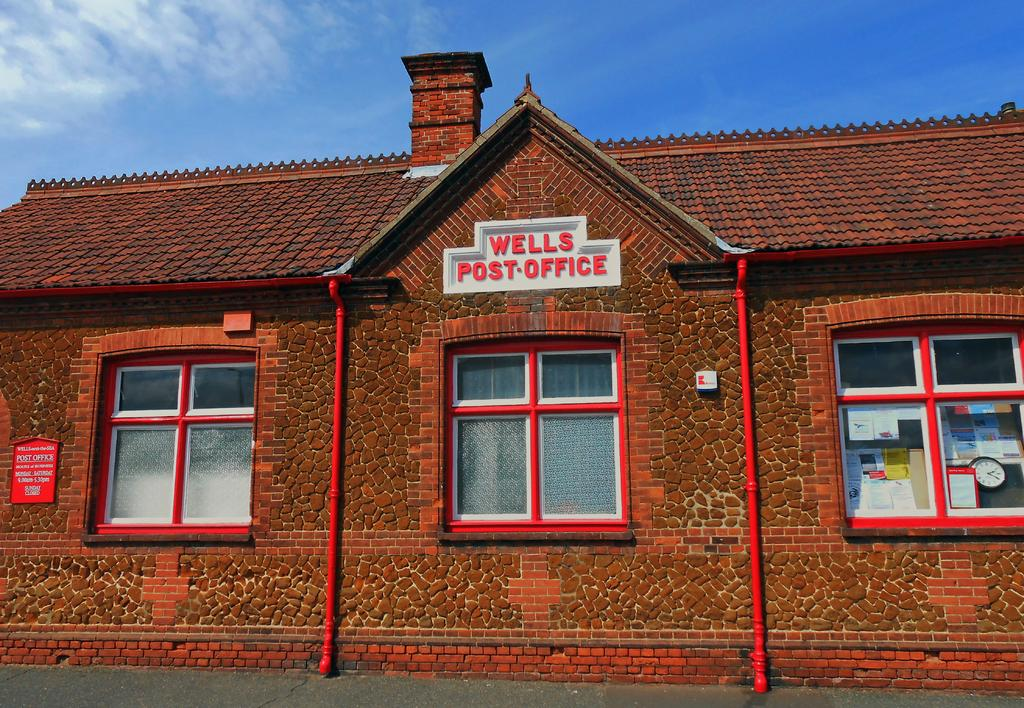What type of structure is depicted in the image? There is a brick wall in the image. How many windows are present on the wall? There are three windows on the wall. What is written on the name plate attached to the wall? The name plate on the wall says "Wells Post Office." What can be seen in the background of the image? The sky is visible in the image. What is the weather like in the image? The sky appears to be sunny, suggesting a clear and bright day. What type of belief is being practiced by the people in the image? There are no people visible in the image, and therefore no beliefs can be observed or inferred. 